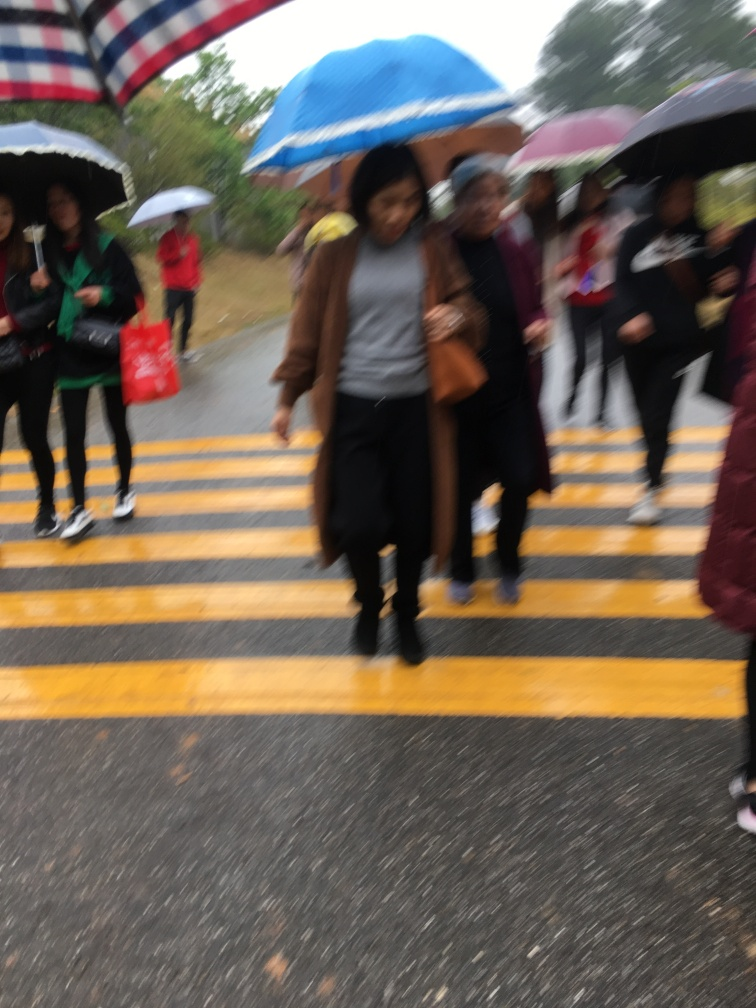Is the picture blurry?
 Yes 